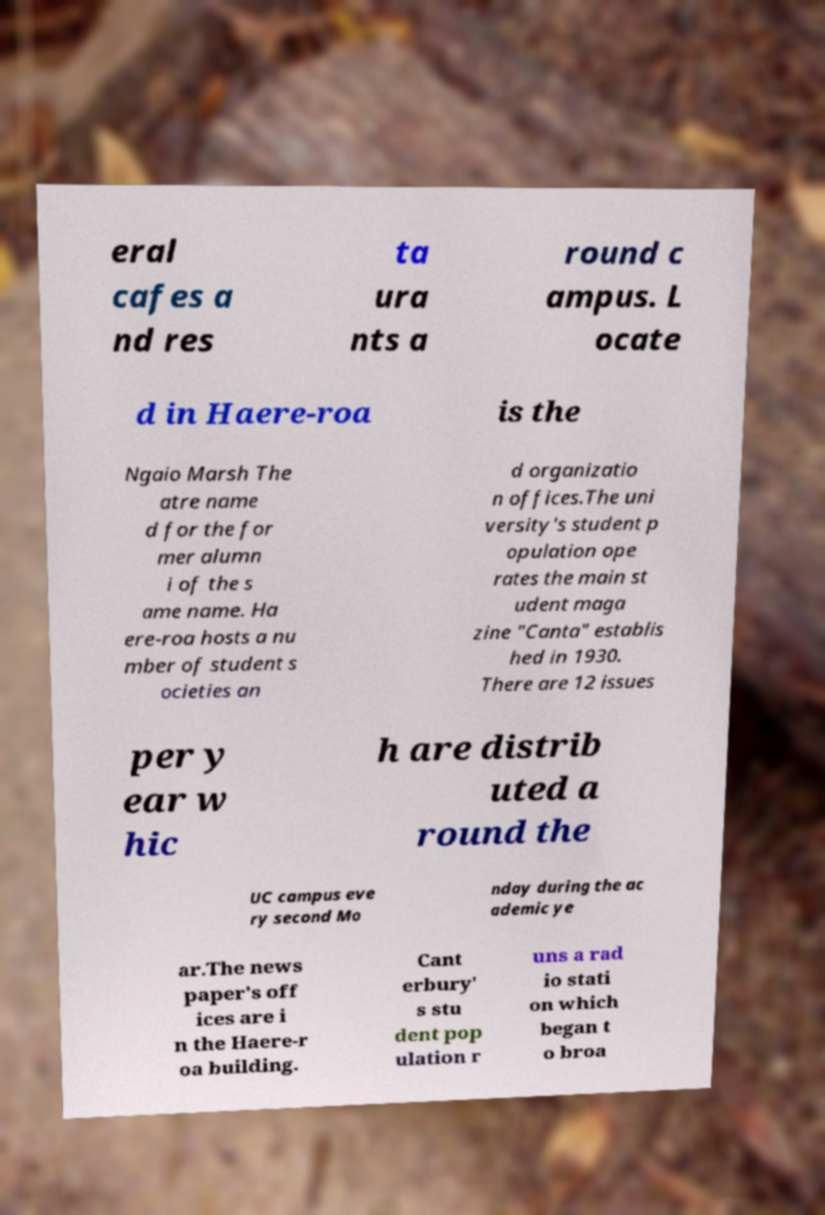Can you read and provide the text displayed in the image?This photo seems to have some interesting text. Can you extract and type it out for me? eral cafes a nd res ta ura nts a round c ampus. L ocate d in Haere-roa is the Ngaio Marsh The atre name d for the for mer alumn i of the s ame name. Ha ere-roa hosts a nu mber of student s ocieties an d organizatio n offices.The uni versity's student p opulation ope rates the main st udent maga zine "Canta" establis hed in 1930. There are 12 issues per y ear w hic h are distrib uted a round the UC campus eve ry second Mo nday during the ac ademic ye ar.The news paper's off ices are i n the Haere-r oa building. Cant erbury' s stu dent pop ulation r uns a rad io stati on which began t o broa 